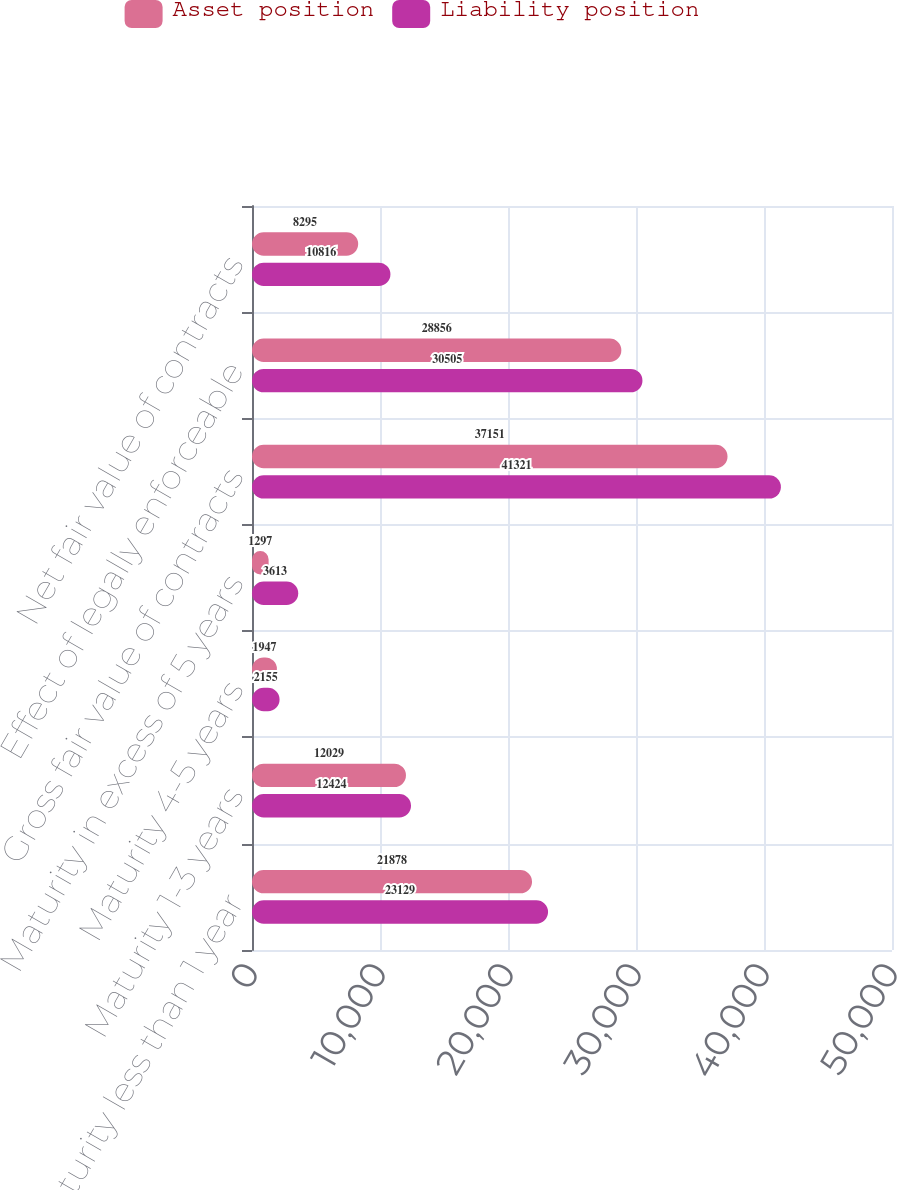<chart> <loc_0><loc_0><loc_500><loc_500><stacked_bar_chart><ecel><fcel>Maturity less than 1 year<fcel>Maturity 1-3 years<fcel>Maturity 4-5 years<fcel>Maturity in excess of 5 years<fcel>Gross fair value of contracts<fcel>Effect of legally enforceable<fcel>Net fair value of contracts<nl><fcel>Asset position<fcel>21878<fcel>12029<fcel>1947<fcel>1297<fcel>37151<fcel>28856<fcel>8295<nl><fcel>Liability position<fcel>23129<fcel>12424<fcel>2155<fcel>3613<fcel>41321<fcel>30505<fcel>10816<nl></chart> 